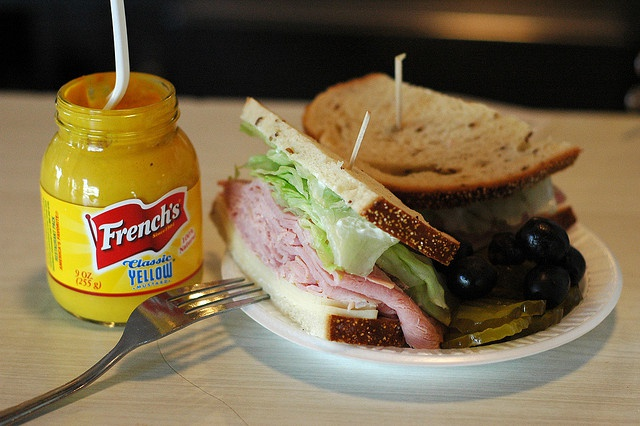Describe the objects in this image and their specific colors. I can see dining table in black, tan, darkgray, olive, and gray tones, sandwich in black, olive, and tan tones, sandwich in black, tan, beige, darkgray, and lightgray tones, and fork in black, gray, and maroon tones in this image. 